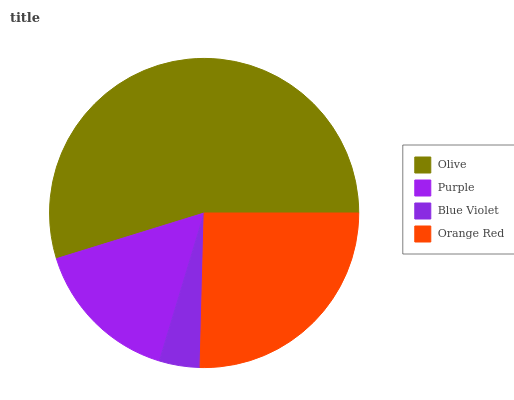Is Blue Violet the minimum?
Answer yes or no. Yes. Is Olive the maximum?
Answer yes or no. Yes. Is Purple the minimum?
Answer yes or no. No. Is Purple the maximum?
Answer yes or no. No. Is Olive greater than Purple?
Answer yes or no. Yes. Is Purple less than Olive?
Answer yes or no. Yes. Is Purple greater than Olive?
Answer yes or no. No. Is Olive less than Purple?
Answer yes or no. No. Is Orange Red the high median?
Answer yes or no. Yes. Is Purple the low median?
Answer yes or no. Yes. Is Purple the high median?
Answer yes or no. No. Is Blue Violet the low median?
Answer yes or no. No. 